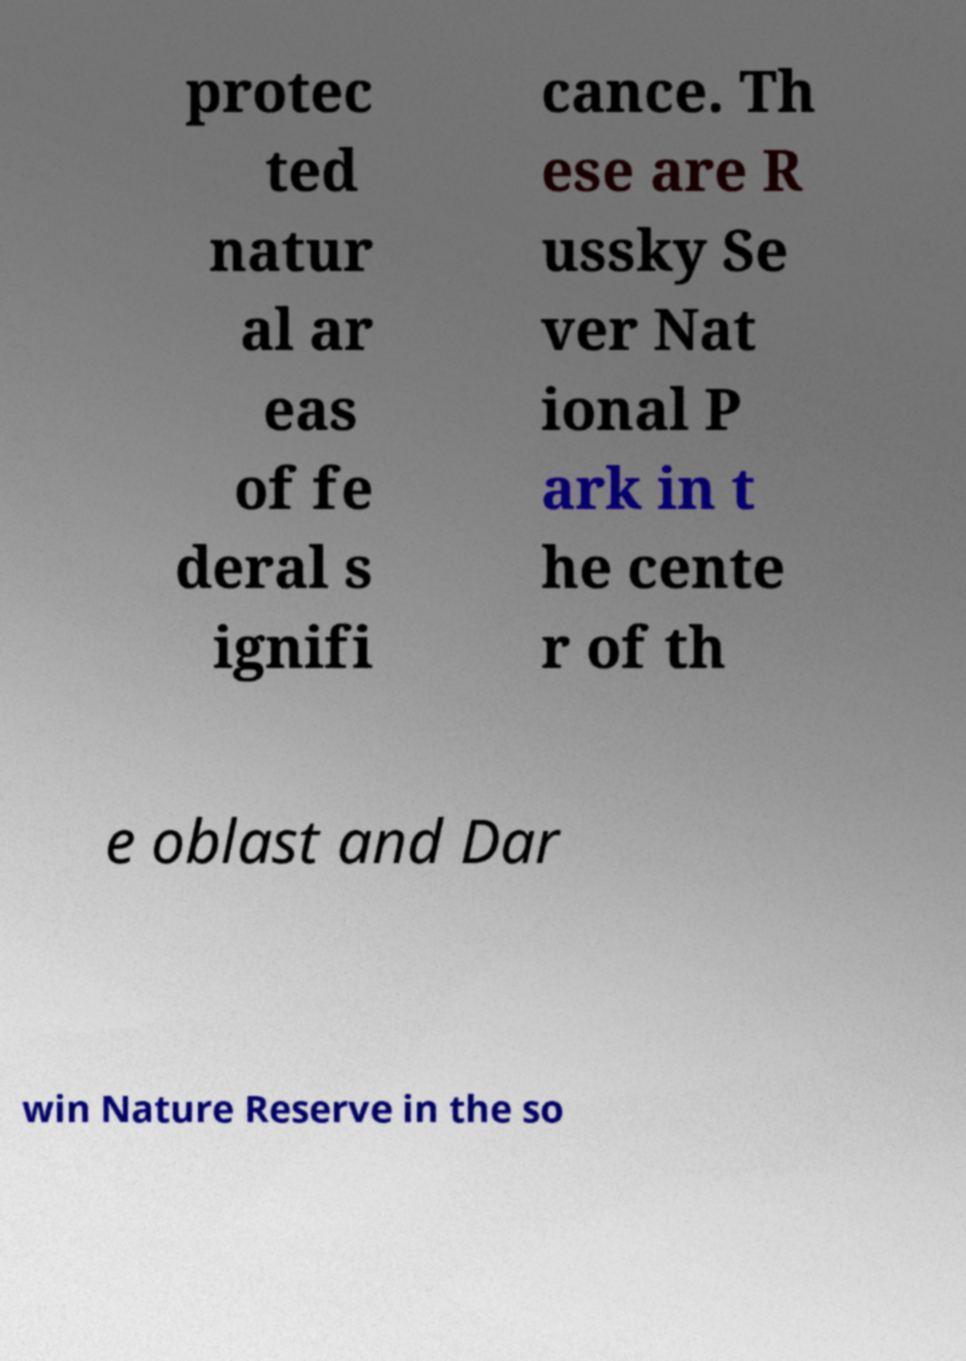I need the written content from this picture converted into text. Can you do that? protec ted natur al ar eas of fe deral s ignifi cance. Th ese are R ussky Se ver Nat ional P ark in t he cente r of th e oblast and Dar win Nature Reserve in the so 